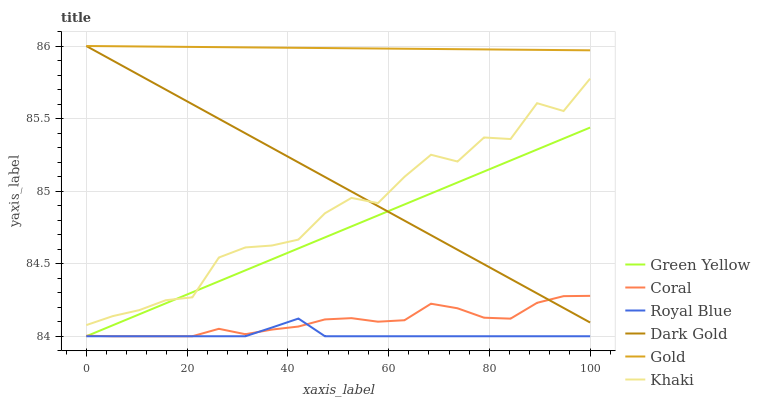Does Royal Blue have the minimum area under the curve?
Answer yes or no. Yes. Does Gold have the maximum area under the curve?
Answer yes or no. Yes. Does Dark Gold have the minimum area under the curve?
Answer yes or no. No. Does Dark Gold have the maximum area under the curve?
Answer yes or no. No. Is Green Yellow the smoothest?
Answer yes or no. Yes. Is Khaki the roughest?
Answer yes or no. Yes. Is Gold the smoothest?
Answer yes or no. No. Is Gold the roughest?
Answer yes or no. No. Does Coral have the lowest value?
Answer yes or no. Yes. Does Dark Gold have the lowest value?
Answer yes or no. No. Does Dark Gold have the highest value?
Answer yes or no. Yes. Does Coral have the highest value?
Answer yes or no. No. Is Royal Blue less than Gold?
Answer yes or no. Yes. Is Gold greater than Coral?
Answer yes or no. Yes. Does Dark Gold intersect Green Yellow?
Answer yes or no. Yes. Is Dark Gold less than Green Yellow?
Answer yes or no. No. Is Dark Gold greater than Green Yellow?
Answer yes or no. No. Does Royal Blue intersect Gold?
Answer yes or no. No. 